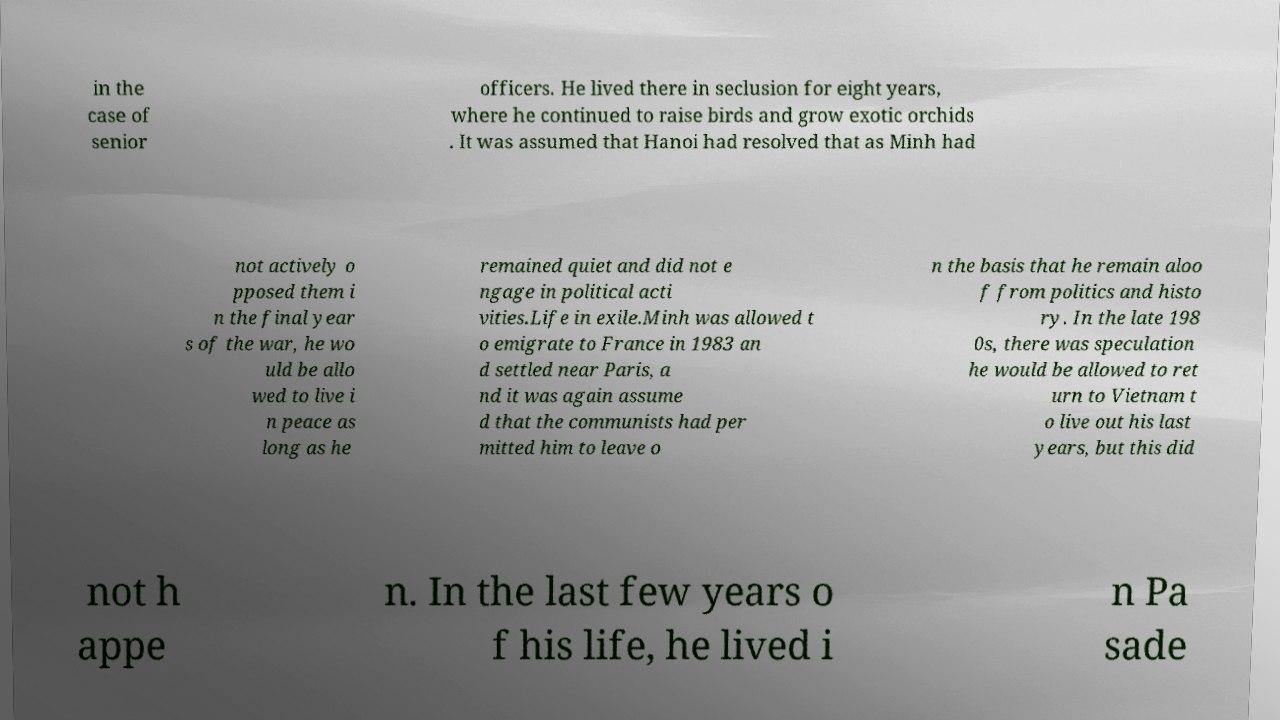Could you assist in decoding the text presented in this image and type it out clearly? in the case of senior officers. He lived there in seclusion for eight years, where he continued to raise birds and grow exotic orchids . It was assumed that Hanoi had resolved that as Minh had not actively o pposed them i n the final year s of the war, he wo uld be allo wed to live i n peace as long as he remained quiet and did not e ngage in political acti vities.Life in exile.Minh was allowed t o emigrate to France in 1983 an d settled near Paris, a nd it was again assume d that the communists had per mitted him to leave o n the basis that he remain aloo f from politics and histo ry. In the late 198 0s, there was speculation he would be allowed to ret urn to Vietnam t o live out his last years, but this did not h appe n. In the last few years o f his life, he lived i n Pa sade 